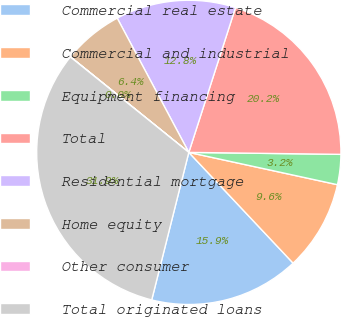<chart> <loc_0><loc_0><loc_500><loc_500><pie_chart><fcel>Commercial real estate<fcel>Commercial and industrial<fcel>Equipment financing<fcel>Total<fcel>Residential mortgage<fcel>Home equity<fcel>Other consumer<fcel>Total originated loans<nl><fcel>15.94%<fcel>9.57%<fcel>3.2%<fcel>20.24%<fcel>12.76%<fcel>6.39%<fcel>0.02%<fcel>31.87%<nl></chart> 